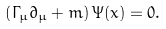<formula> <loc_0><loc_0><loc_500><loc_500>\left ( \Gamma _ { \mu } \partial _ { \mu } + m \right ) \Psi ( x ) = 0 .</formula> 